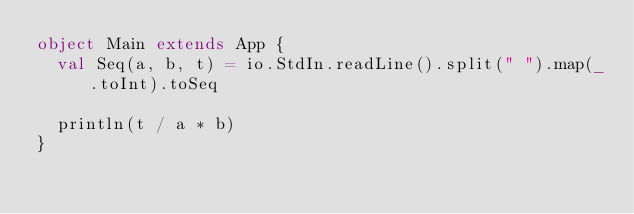Convert code to text. <code><loc_0><loc_0><loc_500><loc_500><_Scala_>object Main extends App {
  val Seq(a, b, t) = io.StdIn.readLine().split(" ").map(_.toInt).toSeq
  
  println(t / a * b)
}</code> 